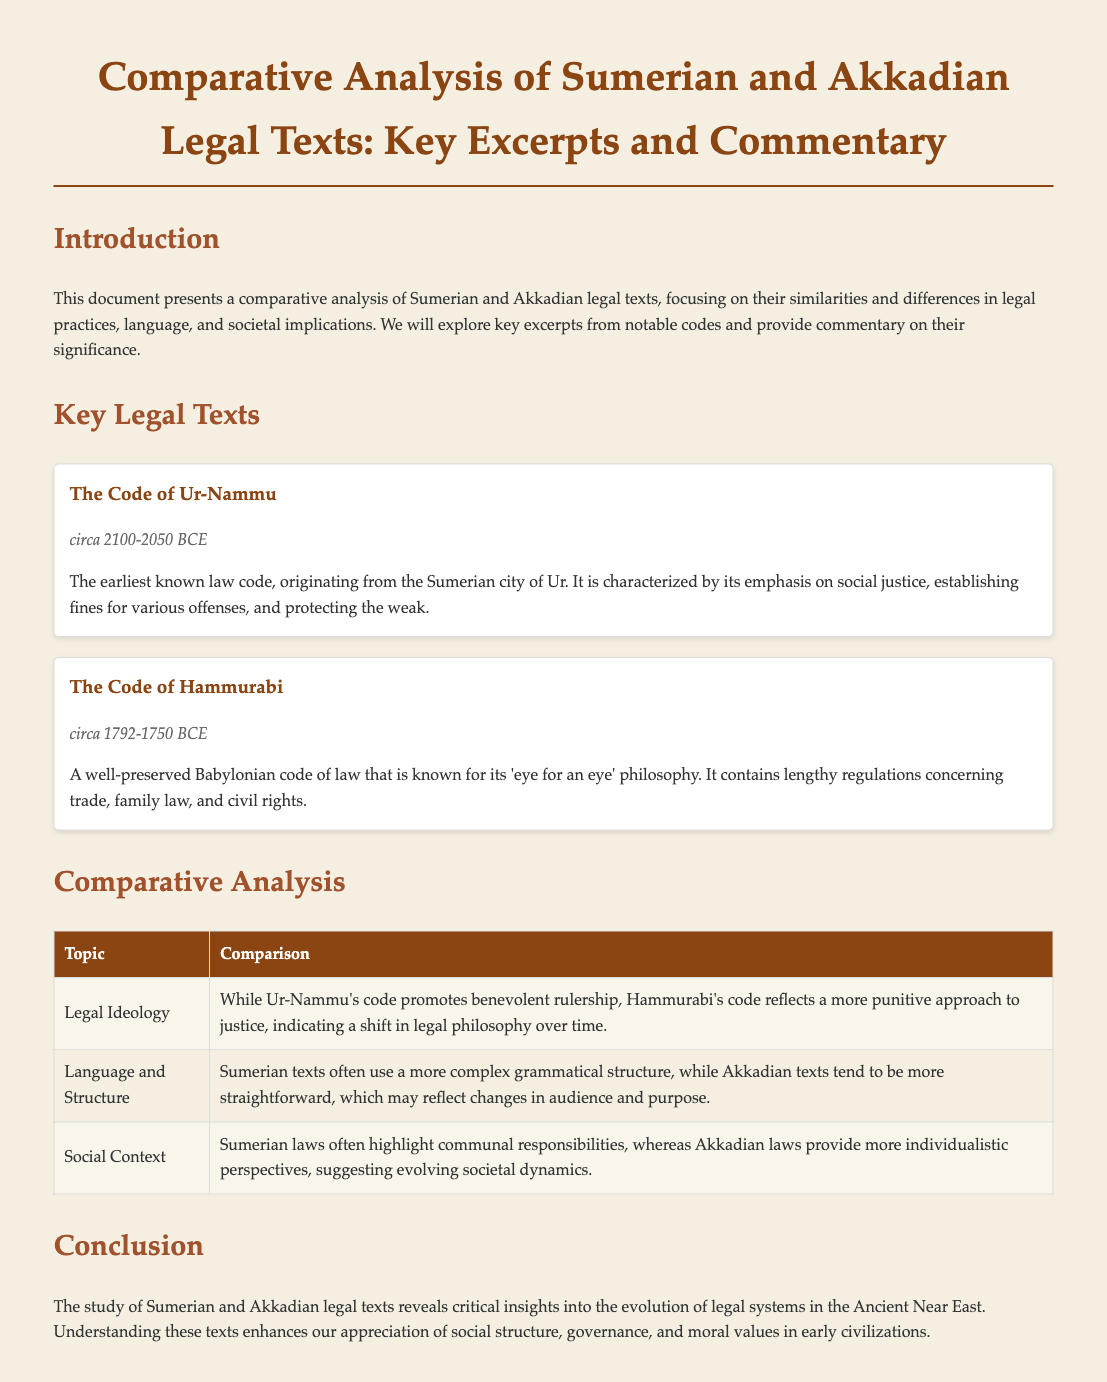What is the title of the document? The title is stated in the header of the document, summarizing the content presented.
Answer: Comparative Analysis of Sumerian and Akkadian Legal Texts What is the date range of The Code of Ur-Nammu? The document specifies the approximate date of this legal text in the date section.
Answer: circa 2100-2050 BCE What legal philosophy is associated with The Code of Hammurabi? The document describes the philosophy related to Hammurabi's code, particularly its focus on justice.
Answer: 'eye for an eye' How many key legal texts are discussed in the document? The document lists the number of prominent legal texts analyzed in the key legal texts section.
Answer: 2 What cultural shift is reflected in the legal ideologies of the two codes? The comparative analysis section discusses the evolution of legal philosophies between the two codes.
Answer: Punitive approach What is the primary focus of Sumerian laws according to the document? The document notes the common themes in Sumerian legal texts regarding their societal implications.
Answer: Communal responsibilities What aspect of language does the document highlight about Sumerian texts? The document mentions a key characteristic of Sumerian texts in comparison to Akkadian texts within the structure topic.
Answer: More complex grammatical structure What does the conclusion emphasize about the study of these legal texts? The closing section summarizes the insights gained from analyzing Sumerian and Akkadian legal systems.
Answer: Evolution of legal systems 